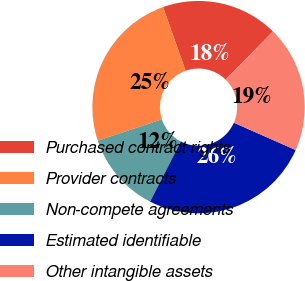<chart> <loc_0><loc_0><loc_500><loc_500><pie_chart><fcel>Purchased contract rights<fcel>Provider contracts<fcel>Non-compete agreements<fcel>Estimated identifiable<fcel>Other intangible assets<nl><fcel>17.78%<fcel>24.69%<fcel>12.35%<fcel>25.93%<fcel>19.26%<nl></chart> 